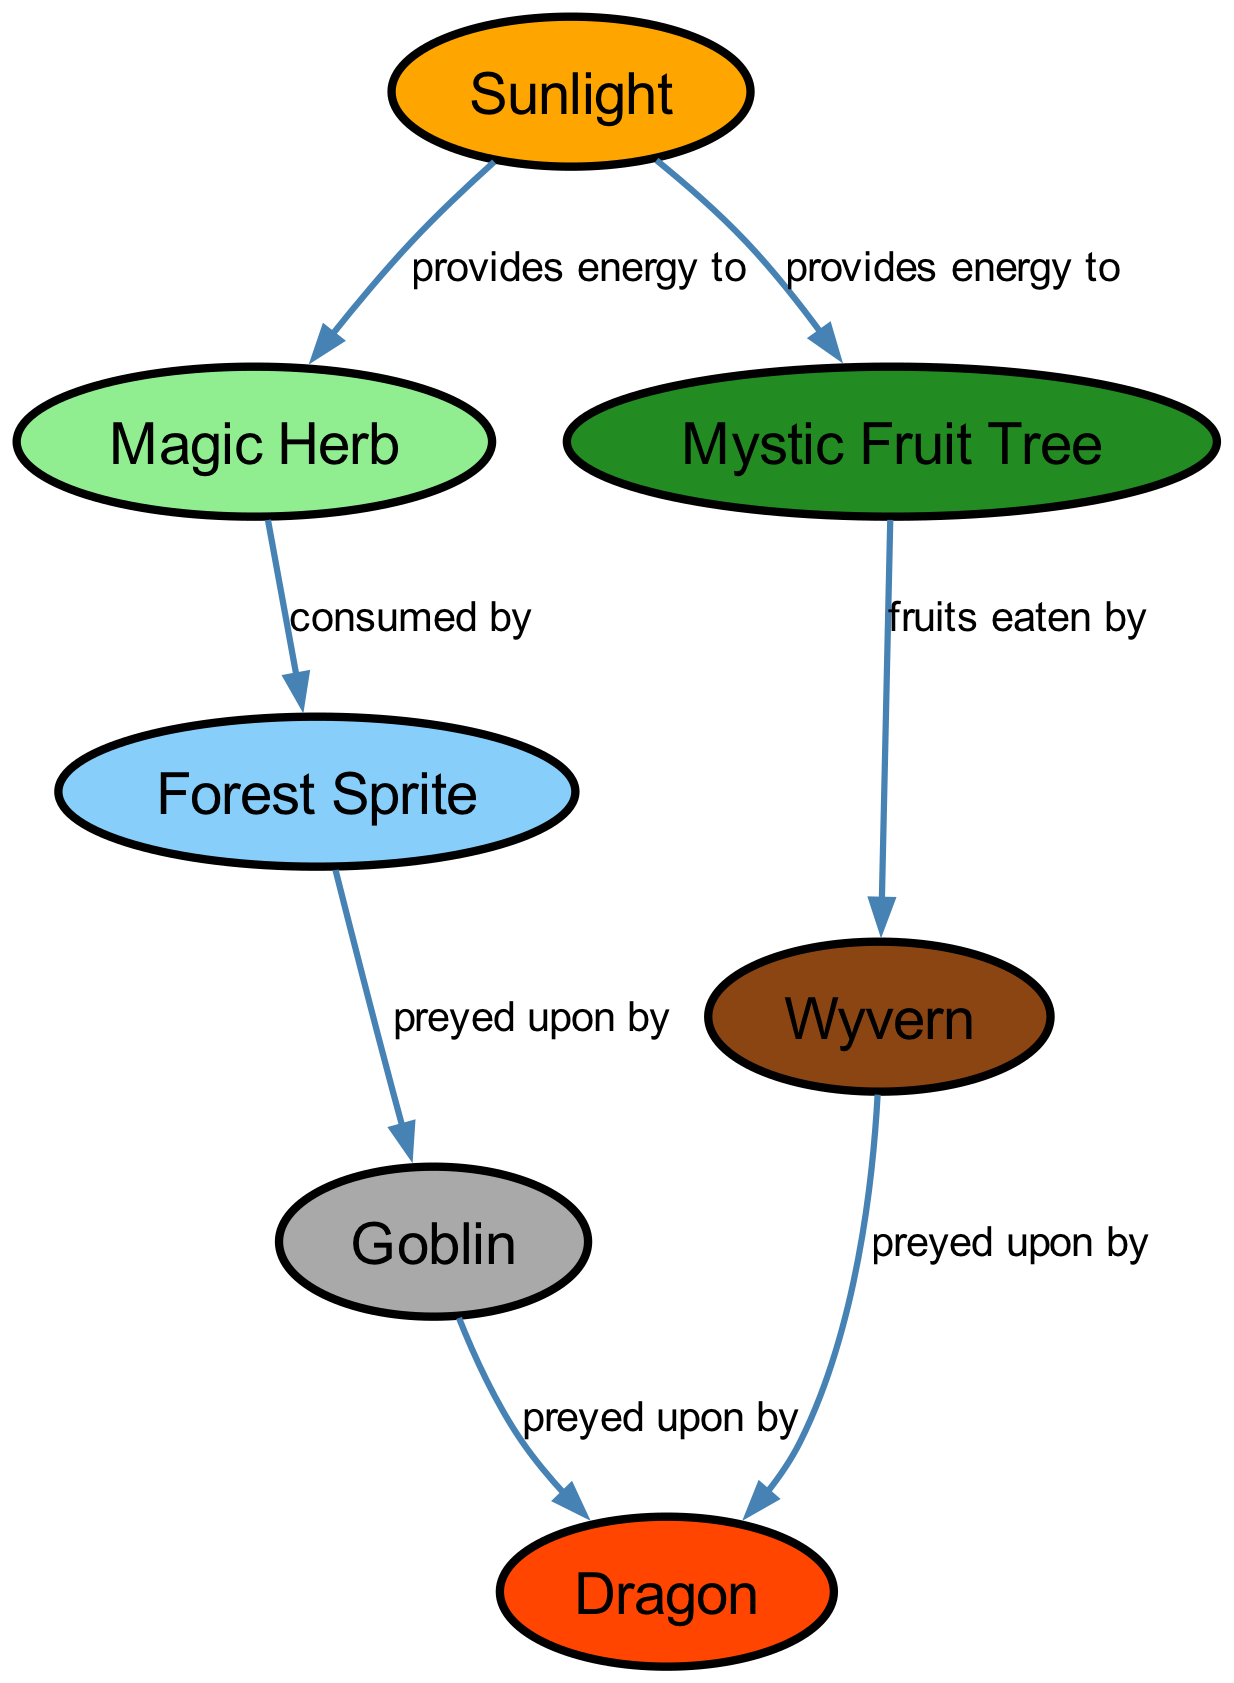What are the primary producers in this food chain? The primary producers are organisms that generate energy from sunlight. According to the diagram, both the Sunlight node and the nodes that it connects to, Magic Herb and Mystic Fruit Tree, are considered primary producers.
Answer: Magic Herb, Mystic Fruit Tree What is the predator of the Goblin? The diagram shows that the Goblin is preyed upon by the Dragon. This can be observed by following the edge labeled "preyed upon by" that connects Goblin to Dragon.
Answer: Dragon How many nodes are present in this food chain diagram? To determine the number of nodes, we can count each unique node in the diagram. The provided data lists seven distinct nodes, which indicates the total count.
Answer: 7 What does the Wyvern eat? According to the diagram, the Wyvern eats the fruits from the Mystic Fruit Tree. This relationship is detailed with an edge labeled "fruits eaten by" from Mystic Fruit Tree to Wyvern.
Answer: Mystic Fruit Tree Which creature is at the top of the food chain? The top predator in the food chain is determined by looking for the creature that is preyed upon but not preyed on itself. In this case, the Dragon is at the top as both the Goblin and Wyvern are indicated to be preyed upon by it.
Answer: Dragon How many creatures directly consume the Magic Herb? The Magic Herb is directly consumed by the Forest Sprite, as indicated by the edge labeled "consumed by" leading to Forest Sprite. No other creature directly consumes Magic Herb in this food chain.
Answer: 1 What is the starting point of energy in this food chain? The starting point of energy in the food chain is the Sunlight. This is shown by the edges originating from the Sunlight node, which provides energy to the Magic Herb and Mystic Fruit Tree nodes.
Answer: Sunlight Which two creatures are on the same level below Wyvern in the food chain? The Wyvern has the Mystic Fruit Tree as its food source, and it is preyed upon by the Dragon. The two creatures below Wyvern are its prey, Goblin, and the Forest Sprite, which can be found one level below it.
Answer: Goblin, Forest Sprite What type of herb is included in the food chain? The diagram identifies the type of herb as the Magic Herb, with a direct link to the light source providing energy for its growth.
Answer: Magic Herb 